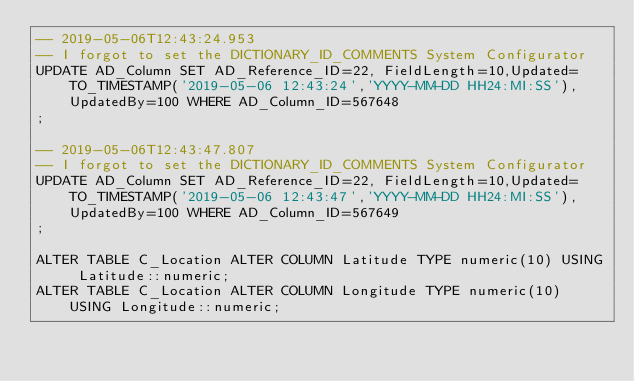Convert code to text. <code><loc_0><loc_0><loc_500><loc_500><_SQL_>-- 2019-05-06T12:43:24.953
-- I forgot to set the DICTIONARY_ID_COMMENTS System Configurator
UPDATE AD_Column SET AD_Reference_ID=22, FieldLength=10,Updated=TO_TIMESTAMP('2019-05-06 12:43:24','YYYY-MM-DD HH24:MI:SS'),UpdatedBy=100 WHERE AD_Column_ID=567648
;

-- 2019-05-06T12:43:47.807
-- I forgot to set the DICTIONARY_ID_COMMENTS System Configurator
UPDATE AD_Column SET AD_Reference_ID=22, FieldLength=10,Updated=TO_TIMESTAMP('2019-05-06 12:43:47','YYYY-MM-DD HH24:MI:SS'),UpdatedBy=100 WHERE AD_Column_ID=567649
;

ALTER TABLE C_Location ALTER COLUMN Latitude TYPE numeric(10) USING Latitude::numeric;
ALTER TABLE C_Location ALTER COLUMN Longitude TYPE numeric(10) USING Longitude::numeric;

</code> 